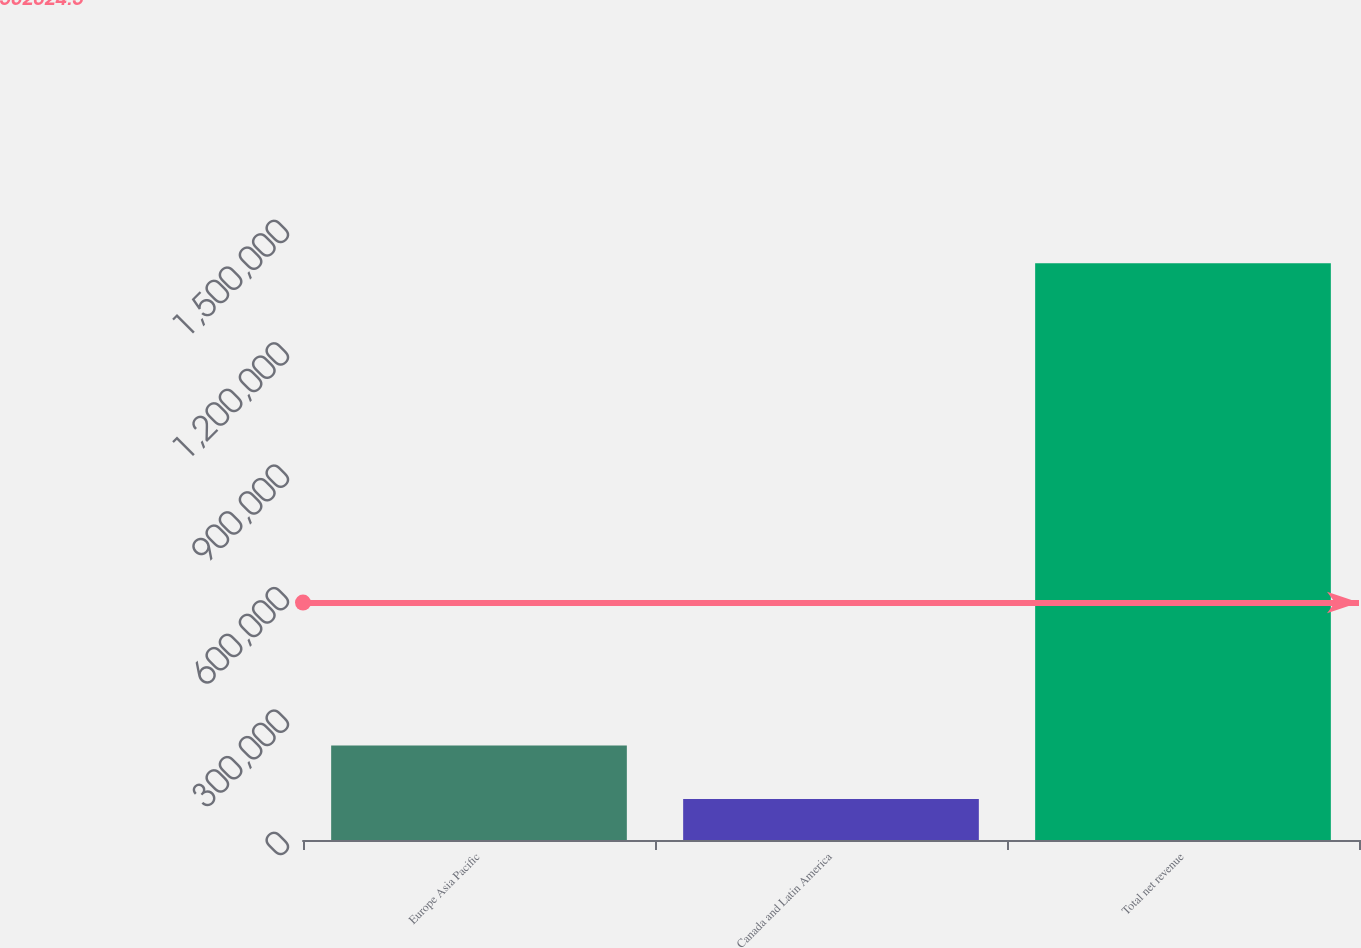Convert chart. <chart><loc_0><loc_0><loc_500><loc_500><bar_chart><fcel>Europe Asia Pacific<fcel>Canada and Latin America<fcel>Total net revenue<nl><fcel>231846<fcel>100529<fcel>1.4137e+06<nl></chart> 